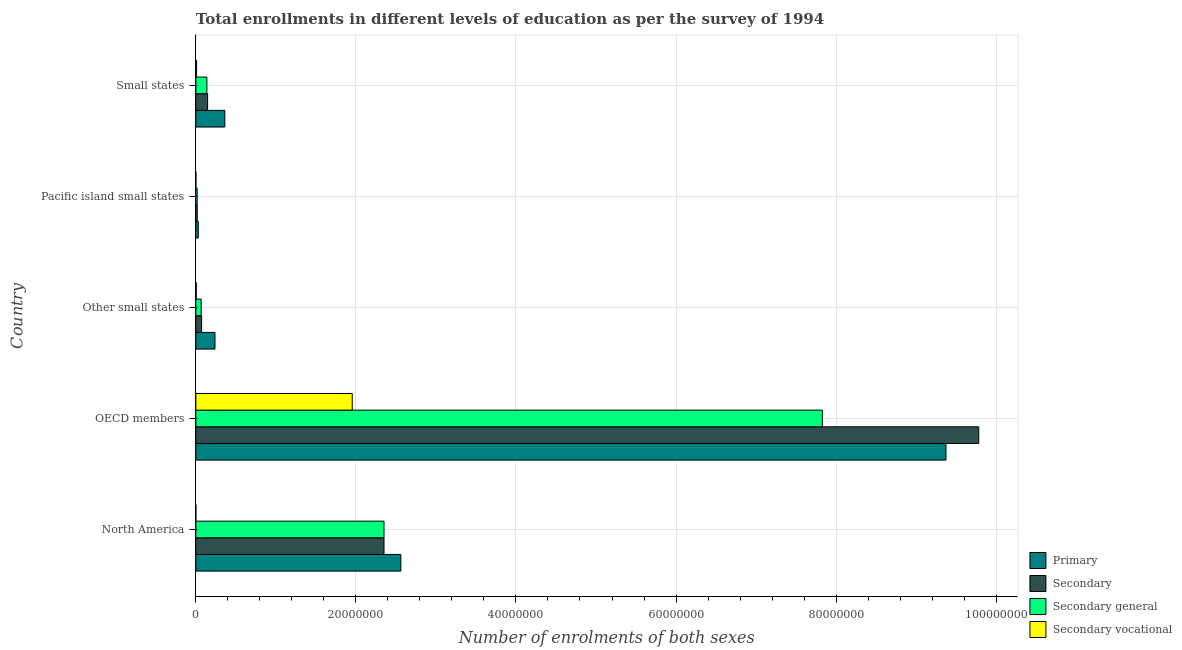How many different coloured bars are there?
Provide a succinct answer. 4. How many groups of bars are there?
Offer a very short reply. 5. Are the number of bars per tick equal to the number of legend labels?
Offer a very short reply. Yes. How many bars are there on the 2nd tick from the top?
Make the answer very short. 4. How many bars are there on the 5th tick from the bottom?
Your answer should be very brief. 4. What is the label of the 3rd group of bars from the top?
Keep it short and to the point. Other small states. What is the number of enrolments in secondary vocational education in Other small states?
Your answer should be compact. 5.53e+04. Across all countries, what is the maximum number of enrolments in primary education?
Ensure brevity in your answer.  9.37e+07. Across all countries, what is the minimum number of enrolments in secondary education?
Provide a succinct answer. 1.76e+05. In which country was the number of enrolments in secondary general education maximum?
Offer a very short reply. OECD members. What is the total number of enrolments in secondary general education in the graph?
Your answer should be very brief. 1.04e+08. What is the difference between the number of enrolments in secondary general education in Pacific island small states and that in Small states?
Ensure brevity in your answer.  -1.21e+06. What is the difference between the number of enrolments in secondary general education in Pacific island small states and the number of enrolments in primary education in North America?
Keep it short and to the point. -2.55e+07. What is the average number of enrolments in primary education per country?
Provide a short and direct response. 2.51e+07. What is the difference between the number of enrolments in secondary vocational education and number of enrolments in secondary general education in Small states?
Keep it short and to the point. -1.29e+06. In how many countries, is the number of enrolments in primary education greater than 8000000 ?
Your answer should be compact. 2. What is the ratio of the number of enrolments in primary education in North America to that in Small states?
Provide a succinct answer. 7.07. Is the difference between the number of enrolments in secondary education in North America and Other small states greater than the difference between the number of enrolments in secondary vocational education in North America and Other small states?
Your answer should be compact. Yes. What is the difference between the highest and the second highest number of enrolments in primary education?
Make the answer very short. 6.81e+07. What is the difference between the highest and the lowest number of enrolments in primary education?
Your response must be concise. 9.34e+07. Is it the case that in every country, the sum of the number of enrolments in secondary vocational education and number of enrolments in secondary education is greater than the sum of number of enrolments in secondary general education and number of enrolments in primary education?
Make the answer very short. Yes. What does the 1st bar from the top in North America represents?
Ensure brevity in your answer.  Secondary vocational. What does the 3rd bar from the bottom in Pacific island small states represents?
Provide a succinct answer. Secondary general. Is it the case that in every country, the sum of the number of enrolments in primary education and number of enrolments in secondary education is greater than the number of enrolments in secondary general education?
Make the answer very short. Yes. How many bars are there?
Your answer should be very brief. 20. How many countries are there in the graph?
Provide a short and direct response. 5. Does the graph contain grids?
Ensure brevity in your answer.  Yes. Where does the legend appear in the graph?
Provide a short and direct response. Bottom right. How are the legend labels stacked?
Your answer should be very brief. Vertical. What is the title of the graph?
Keep it short and to the point. Total enrollments in different levels of education as per the survey of 1994. What is the label or title of the X-axis?
Provide a succinct answer. Number of enrolments of both sexes. What is the label or title of the Y-axis?
Provide a short and direct response. Country. What is the Number of enrolments of both sexes of Primary in North America?
Keep it short and to the point. 2.56e+07. What is the Number of enrolments of both sexes of Secondary in North America?
Your answer should be very brief. 2.35e+07. What is the Number of enrolments of both sexes of Secondary general in North America?
Offer a terse response. 2.35e+07. What is the Number of enrolments of both sexes in Secondary vocational in North America?
Offer a very short reply. 45.26. What is the Number of enrolments of both sexes of Primary in OECD members?
Give a very brief answer. 9.37e+07. What is the Number of enrolments of both sexes of Secondary in OECD members?
Offer a terse response. 9.78e+07. What is the Number of enrolments of both sexes in Secondary general in OECD members?
Give a very brief answer. 7.83e+07. What is the Number of enrolments of both sexes of Secondary vocational in OECD members?
Make the answer very short. 1.95e+07. What is the Number of enrolments of both sexes of Primary in Other small states?
Your response must be concise. 2.39e+06. What is the Number of enrolments of both sexes of Secondary in Other small states?
Make the answer very short. 7.22e+05. What is the Number of enrolments of both sexes in Secondary general in Other small states?
Offer a terse response. 6.66e+05. What is the Number of enrolments of both sexes of Secondary vocational in Other small states?
Your answer should be compact. 5.53e+04. What is the Number of enrolments of both sexes in Primary in Pacific island small states?
Keep it short and to the point. 3.11e+05. What is the Number of enrolments of both sexes of Secondary in Pacific island small states?
Make the answer very short. 1.76e+05. What is the Number of enrolments of both sexes of Secondary general in Pacific island small states?
Ensure brevity in your answer.  1.69e+05. What is the Number of enrolments of both sexes in Secondary vocational in Pacific island small states?
Keep it short and to the point. 7581.44. What is the Number of enrolments of both sexes of Primary in Small states?
Provide a short and direct response. 3.62e+06. What is the Number of enrolments of both sexes in Secondary in Small states?
Offer a very short reply. 1.47e+06. What is the Number of enrolments of both sexes of Secondary general in Small states?
Offer a terse response. 1.38e+06. What is the Number of enrolments of both sexes in Secondary vocational in Small states?
Provide a short and direct response. 9.29e+04. Across all countries, what is the maximum Number of enrolments of both sexes of Primary?
Provide a short and direct response. 9.37e+07. Across all countries, what is the maximum Number of enrolments of both sexes in Secondary?
Your response must be concise. 9.78e+07. Across all countries, what is the maximum Number of enrolments of both sexes of Secondary general?
Ensure brevity in your answer.  7.83e+07. Across all countries, what is the maximum Number of enrolments of both sexes in Secondary vocational?
Make the answer very short. 1.95e+07. Across all countries, what is the minimum Number of enrolments of both sexes in Primary?
Provide a short and direct response. 3.11e+05. Across all countries, what is the minimum Number of enrolments of both sexes in Secondary?
Keep it short and to the point. 1.76e+05. Across all countries, what is the minimum Number of enrolments of both sexes of Secondary general?
Keep it short and to the point. 1.69e+05. Across all countries, what is the minimum Number of enrolments of both sexes of Secondary vocational?
Provide a short and direct response. 45.26. What is the total Number of enrolments of both sexes of Primary in the graph?
Make the answer very short. 1.26e+08. What is the total Number of enrolments of both sexes in Secondary in the graph?
Offer a very short reply. 1.24e+08. What is the total Number of enrolments of both sexes of Secondary general in the graph?
Make the answer very short. 1.04e+08. What is the total Number of enrolments of both sexes of Secondary vocational in the graph?
Ensure brevity in your answer.  1.97e+07. What is the difference between the Number of enrolments of both sexes of Primary in North America and that in OECD members?
Keep it short and to the point. -6.81e+07. What is the difference between the Number of enrolments of both sexes in Secondary in North America and that in OECD members?
Give a very brief answer. -7.43e+07. What is the difference between the Number of enrolments of both sexes in Secondary general in North America and that in OECD members?
Your response must be concise. -5.48e+07. What is the difference between the Number of enrolments of both sexes of Secondary vocational in North America and that in OECD members?
Your answer should be very brief. -1.95e+07. What is the difference between the Number of enrolments of both sexes in Primary in North America and that in Other small states?
Make the answer very short. 2.32e+07. What is the difference between the Number of enrolments of both sexes of Secondary in North America and that in Other small states?
Give a very brief answer. 2.28e+07. What is the difference between the Number of enrolments of both sexes of Secondary general in North America and that in Other small states?
Provide a succinct answer. 2.28e+07. What is the difference between the Number of enrolments of both sexes in Secondary vocational in North America and that in Other small states?
Give a very brief answer. -5.52e+04. What is the difference between the Number of enrolments of both sexes of Primary in North America and that in Pacific island small states?
Offer a very short reply. 2.53e+07. What is the difference between the Number of enrolments of both sexes in Secondary in North America and that in Pacific island small states?
Provide a short and direct response. 2.33e+07. What is the difference between the Number of enrolments of both sexes in Secondary general in North America and that in Pacific island small states?
Offer a very short reply. 2.33e+07. What is the difference between the Number of enrolments of both sexes of Secondary vocational in North America and that in Pacific island small states?
Offer a very short reply. -7536.18. What is the difference between the Number of enrolments of both sexes in Primary in North America and that in Small states?
Your answer should be very brief. 2.20e+07. What is the difference between the Number of enrolments of both sexes of Secondary in North America and that in Small states?
Your answer should be very brief. 2.20e+07. What is the difference between the Number of enrolments of both sexes in Secondary general in North America and that in Small states?
Ensure brevity in your answer.  2.21e+07. What is the difference between the Number of enrolments of both sexes of Secondary vocational in North America and that in Small states?
Your answer should be compact. -9.29e+04. What is the difference between the Number of enrolments of both sexes in Primary in OECD members and that in Other small states?
Provide a short and direct response. 9.13e+07. What is the difference between the Number of enrolments of both sexes of Secondary in OECD members and that in Other small states?
Offer a very short reply. 9.71e+07. What is the difference between the Number of enrolments of both sexes in Secondary general in OECD members and that in Other small states?
Provide a succinct answer. 7.76e+07. What is the difference between the Number of enrolments of both sexes in Secondary vocational in OECD members and that in Other small states?
Provide a short and direct response. 1.95e+07. What is the difference between the Number of enrolments of both sexes in Primary in OECD members and that in Pacific island small states?
Keep it short and to the point. 9.34e+07. What is the difference between the Number of enrolments of both sexes in Secondary in OECD members and that in Pacific island small states?
Keep it short and to the point. 9.77e+07. What is the difference between the Number of enrolments of both sexes of Secondary general in OECD members and that in Pacific island small states?
Provide a short and direct response. 7.81e+07. What is the difference between the Number of enrolments of both sexes in Secondary vocational in OECD members and that in Pacific island small states?
Provide a short and direct response. 1.95e+07. What is the difference between the Number of enrolments of both sexes of Primary in OECD members and that in Small states?
Make the answer very short. 9.01e+07. What is the difference between the Number of enrolments of both sexes in Secondary in OECD members and that in Small states?
Provide a short and direct response. 9.64e+07. What is the difference between the Number of enrolments of both sexes of Secondary general in OECD members and that in Small states?
Provide a short and direct response. 7.69e+07. What is the difference between the Number of enrolments of both sexes in Secondary vocational in OECD members and that in Small states?
Provide a succinct answer. 1.95e+07. What is the difference between the Number of enrolments of both sexes in Primary in Other small states and that in Pacific island small states?
Your answer should be compact. 2.08e+06. What is the difference between the Number of enrolments of both sexes in Secondary in Other small states and that in Pacific island small states?
Your answer should be very brief. 5.45e+05. What is the difference between the Number of enrolments of both sexes of Secondary general in Other small states and that in Pacific island small states?
Provide a succinct answer. 4.98e+05. What is the difference between the Number of enrolments of both sexes of Secondary vocational in Other small states and that in Pacific island small states?
Offer a very short reply. 4.77e+04. What is the difference between the Number of enrolments of both sexes in Primary in Other small states and that in Small states?
Your answer should be compact. -1.23e+06. What is the difference between the Number of enrolments of both sexes in Secondary in Other small states and that in Small states?
Offer a very short reply. -7.50e+05. What is the difference between the Number of enrolments of both sexes of Secondary general in Other small states and that in Small states?
Your answer should be very brief. -7.13e+05. What is the difference between the Number of enrolments of both sexes in Secondary vocational in Other small states and that in Small states?
Your response must be concise. -3.76e+04. What is the difference between the Number of enrolments of both sexes of Primary in Pacific island small states and that in Small states?
Offer a very short reply. -3.31e+06. What is the difference between the Number of enrolments of both sexes of Secondary in Pacific island small states and that in Small states?
Your answer should be very brief. -1.30e+06. What is the difference between the Number of enrolments of both sexes of Secondary general in Pacific island small states and that in Small states?
Keep it short and to the point. -1.21e+06. What is the difference between the Number of enrolments of both sexes of Secondary vocational in Pacific island small states and that in Small states?
Your response must be concise. -8.53e+04. What is the difference between the Number of enrolments of both sexes of Primary in North America and the Number of enrolments of both sexes of Secondary in OECD members?
Ensure brevity in your answer.  -7.22e+07. What is the difference between the Number of enrolments of both sexes in Primary in North America and the Number of enrolments of both sexes in Secondary general in OECD members?
Provide a succinct answer. -5.27e+07. What is the difference between the Number of enrolments of both sexes in Primary in North America and the Number of enrolments of both sexes in Secondary vocational in OECD members?
Your answer should be very brief. 6.08e+06. What is the difference between the Number of enrolments of both sexes in Secondary in North America and the Number of enrolments of both sexes in Secondary general in OECD members?
Keep it short and to the point. -5.48e+07. What is the difference between the Number of enrolments of both sexes of Secondary in North America and the Number of enrolments of both sexes of Secondary vocational in OECD members?
Your response must be concise. 3.97e+06. What is the difference between the Number of enrolments of both sexes in Secondary general in North America and the Number of enrolments of both sexes in Secondary vocational in OECD members?
Your response must be concise. 3.97e+06. What is the difference between the Number of enrolments of both sexes of Primary in North America and the Number of enrolments of both sexes of Secondary in Other small states?
Your response must be concise. 2.49e+07. What is the difference between the Number of enrolments of both sexes of Primary in North America and the Number of enrolments of both sexes of Secondary general in Other small states?
Your answer should be very brief. 2.50e+07. What is the difference between the Number of enrolments of both sexes in Primary in North America and the Number of enrolments of both sexes in Secondary vocational in Other small states?
Provide a succinct answer. 2.56e+07. What is the difference between the Number of enrolments of both sexes in Secondary in North America and the Number of enrolments of both sexes in Secondary general in Other small states?
Provide a short and direct response. 2.28e+07. What is the difference between the Number of enrolments of both sexes of Secondary in North America and the Number of enrolments of both sexes of Secondary vocational in Other small states?
Make the answer very short. 2.35e+07. What is the difference between the Number of enrolments of both sexes in Secondary general in North America and the Number of enrolments of both sexes in Secondary vocational in Other small states?
Provide a short and direct response. 2.35e+07. What is the difference between the Number of enrolments of both sexes of Primary in North America and the Number of enrolments of both sexes of Secondary in Pacific island small states?
Your response must be concise. 2.54e+07. What is the difference between the Number of enrolments of both sexes in Primary in North America and the Number of enrolments of both sexes in Secondary general in Pacific island small states?
Ensure brevity in your answer.  2.55e+07. What is the difference between the Number of enrolments of both sexes of Primary in North America and the Number of enrolments of both sexes of Secondary vocational in Pacific island small states?
Your response must be concise. 2.56e+07. What is the difference between the Number of enrolments of both sexes of Secondary in North America and the Number of enrolments of both sexes of Secondary general in Pacific island small states?
Make the answer very short. 2.33e+07. What is the difference between the Number of enrolments of both sexes of Secondary in North America and the Number of enrolments of both sexes of Secondary vocational in Pacific island small states?
Provide a short and direct response. 2.35e+07. What is the difference between the Number of enrolments of both sexes of Secondary general in North America and the Number of enrolments of both sexes of Secondary vocational in Pacific island small states?
Offer a very short reply. 2.35e+07. What is the difference between the Number of enrolments of both sexes of Primary in North America and the Number of enrolments of both sexes of Secondary in Small states?
Your answer should be very brief. 2.41e+07. What is the difference between the Number of enrolments of both sexes in Primary in North America and the Number of enrolments of both sexes in Secondary general in Small states?
Ensure brevity in your answer.  2.42e+07. What is the difference between the Number of enrolments of both sexes of Primary in North America and the Number of enrolments of both sexes of Secondary vocational in Small states?
Ensure brevity in your answer.  2.55e+07. What is the difference between the Number of enrolments of both sexes in Secondary in North America and the Number of enrolments of both sexes in Secondary general in Small states?
Your response must be concise. 2.21e+07. What is the difference between the Number of enrolments of both sexes of Secondary in North America and the Number of enrolments of both sexes of Secondary vocational in Small states?
Ensure brevity in your answer.  2.34e+07. What is the difference between the Number of enrolments of both sexes of Secondary general in North America and the Number of enrolments of both sexes of Secondary vocational in Small states?
Offer a terse response. 2.34e+07. What is the difference between the Number of enrolments of both sexes in Primary in OECD members and the Number of enrolments of both sexes in Secondary in Other small states?
Make the answer very short. 9.30e+07. What is the difference between the Number of enrolments of both sexes in Primary in OECD members and the Number of enrolments of both sexes in Secondary general in Other small states?
Offer a very short reply. 9.31e+07. What is the difference between the Number of enrolments of both sexes of Primary in OECD members and the Number of enrolments of both sexes of Secondary vocational in Other small states?
Provide a short and direct response. 9.37e+07. What is the difference between the Number of enrolments of both sexes of Secondary in OECD members and the Number of enrolments of both sexes of Secondary general in Other small states?
Offer a terse response. 9.72e+07. What is the difference between the Number of enrolments of both sexes of Secondary in OECD members and the Number of enrolments of both sexes of Secondary vocational in Other small states?
Offer a very short reply. 9.78e+07. What is the difference between the Number of enrolments of both sexes in Secondary general in OECD members and the Number of enrolments of both sexes in Secondary vocational in Other small states?
Ensure brevity in your answer.  7.82e+07. What is the difference between the Number of enrolments of both sexes of Primary in OECD members and the Number of enrolments of both sexes of Secondary in Pacific island small states?
Keep it short and to the point. 9.36e+07. What is the difference between the Number of enrolments of both sexes of Primary in OECD members and the Number of enrolments of both sexes of Secondary general in Pacific island small states?
Provide a short and direct response. 9.36e+07. What is the difference between the Number of enrolments of both sexes of Primary in OECD members and the Number of enrolments of both sexes of Secondary vocational in Pacific island small states?
Your answer should be compact. 9.37e+07. What is the difference between the Number of enrolments of both sexes of Secondary in OECD members and the Number of enrolments of both sexes of Secondary general in Pacific island small states?
Give a very brief answer. 9.77e+07. What is the difference between the Number of enrolments of both sexes of Secondary in OECD members and the Number of enrolments of both sexes of Secondary vocational in Pacific island small states?
Offer a very short reply. 9.78e+07. What is the difference between the Number of enrolments of both sexes of Secondary general in OECD members and the Number of enrolments of both sexes of Secondary vocational in Pacific island small states?
Keep it short and to the point. 7.83e+07. What is the difference between the Number of enrolments of both sexes in Primary in OECD members and the Number of enrolments of both sexes in Secondary in Small states?
Offer a very short reply. 9.23e+07. What is the difference between the Number of enrolments of both sexes of Primary in OECD members and the Number of enrolments of both sexes of Secondary general in Small states?
Keep it short and to the point. 9.24e+07. What is the difference between the Number of enrolments of both sexes in Primary in OECD members and the Number of enrolments of both sexes in Secondary vocational in Small states?
Make the answer very short. 9.36e+07. What is the difference between the Number of enrolments of both sexes of Secondary in OECD members and the Number of enrolments of both sexes of Secondary general in Small states?
Provide a short and direct response. 9.64e+07. What is the difference between the Number of enrolments of both sexes in Secondary in OECD members and the Number of enrolments of both sexes in Secondary vocational in Small states?
Provide a succinct answer. 9.77e+07. What is the difference between the Number of enrolments of both sexes in Secondary general in OECD members and the Number of enrolments of both sexes in Secondary vocational in Small states?
Provide a short and direct response. 7.82e+07. What is the difference between the Number of enrolments of both sexes in Primary in Other small states and the Number of enrolments of both sexes in Secondary in Pacific island small states?
Your response must be concise. 2.22e+06. What is the difference between the Number of enrolments of both sexes in Primary in Other small states and the Number of enrolments of both sexes in Secondary general in Pacific island small states?
Keep it short and to the point. 2.22e+06. What is the difference between the Number of enrolments of both sexes of Primary in Other small states and the Number of enrolments of both sexes of Secondary vocational in Pacific island small states?
Offer a terse response. 2.39e+06. What is the difference between the Number of enrolments of both sexes of Secondary in Other small states and the Number of enrolments of both sexes of Secondary general in Pacific island small states?
Offer a very short reply. 5.53e+05. What is the difference between the Number of enrolments of both sexes in Secondary in Other small states and the Number of enrolments of both sexes in Secondary vocational in Pacific island small states?
Your answer should be compact. 7.14e+05. What is the difference between the Number of enrolments of both sexes in Secondary general in Other small states and the Number of enrolments of both sexes in Secondary vocational in Pacific island small states?
Your answer should be very brief. 6.59e+05. What is the difference between the Number of enrolments of both sexes of Primary in Other small states and the Number of enrolments of both sexes of Secondary in Small states?
Keep it short and to the point. 9.21e+05. What is the difference between the Number of enrolments of both sexes of Primary in Other small states and the Number of enrolments of both sexes of Secondary general in Small states?
Make the answer very short. 1.01e+06. What is the difference between the Number of enrolments of both sexes of Primary in Other small states and the Number of enrolments of both sexes of Secondary vocational in Small states?
Your answer should be compact. 2.30e+06. What is the difference between the Number of enrolments of both sexes in Secondary in Other small states and the Number of enrolments of both sexes in Secondary general in Small states?
Ensure brevity in your answer.  -6.58e+05. What is the difference between the Number of enrolments of both sexes of Secondary in Other small states and the Number of enrolments of both sexes of Secondary vocational in Small states?
Your response must be concise. 6.29e+05. What is the difference between the Number of enrolments of both sexes in Secondary general in Other small states and the Number of enrolments of both sexes in Secondary vocational in Small states?
Provide a succinct answer. 5.74e+05. What is the difference between the Number of enrolments of both sexes in Primary in Pacific island small states and the Number of enrolments of both sexes in Secondary in Small states?
Your response must be concise. -1.16e+06. What is the difference between the Number of enrolments of both sexes of Primary in Pacific island small states and the Number of enrolments of both sexes of Secondary general in Small states?
Provide a succinct answer. -1.07e+06. What is the difference between the Number of enrolments of both sexes in Primary in Pacific island small states and the Number of enrolments of both sexes in Secondary vocational in Small states?
Offer a terse response. 2.18e+05. What is the difference between the Number of enrolments of both sexes in Secondary in Pacific island small states and the Number of enrolments of both sexes in Secondary general in Small states?
Offer a very short reply. -1.20e+06. What is the difference between the Number of enrolments of both sexes of Secondary in Pacific island small states and the Number of enrolments of both sexes of Secondary vocational in Small states?
Make the answer very short. 8.35e+04. What is the difference between the Number of enrolments of both sexes in Secondary general in Pacific island small states and the Number of enrolments of both sexes in Secondary vocational in Small states?
Make the answer very short. 7.59e+04. What is the average Number of enrolments of both sexes in Primary per country?
Provide a short and direct response. 2.51e+07. What is the average Number of enrolments of both sexes in Secondary per country?
Make the answer very short. 2.47e+07. What is the average Number of enrolments of both sexes of Secondary general per country?
Give a very brief answer. 2.08e+07. What is the average Number of enrolments of both sexes of Secondary vocational per country?
Provide a succinct answer. 3.94e+06. What is the difference between the Number of enrolments of both sexes in Primary and Number of enrolments of both sexes in Secondary in North America?
Make the answer very short. 2.10e+06. What is the difference between the Number of enrolments of both sexes in Primary and Number of enrolments of both sexes in Secondary general in North America?
Keep it short and to the point. 2.10e+06. What is the difference between the Number of enrolments of both sexes of Primary and Number of enrolments of both sexes of Secondary vocational in North America?
Ensure brevity in your answer.  2.56e+07. What is the difference between the Number of enrolments of both sexes in Secondary and Number of enrolments of both sexes in Secondary vocational in North America?
Your answer should be very brief. 2.35e+07. What is the difference between the Number of enrolments of both sexes in Secondary general and Number of enrolments of both sexes in Secondary vocational in North America?
Provide a short and direct response. 2.35e+07. What is the difference between the Number of enrolments of both sexes of Primary and Number of enrolments of both sexes of Secondary in OECD members?
Your response must be concise. -4.09e+06. What is the difference between the Number of enrolments of both sexes in Primary and Number of enrolments of both sexes in Secondary general in OECD members?
Offer a very short reply. 1.54e+07. What is the difference between the Number of enrolments of both sexes of Primary and Number of enrolments of both sexes of Secondary vocational in OECD members?
Give a very brief answer. 7.42e+07. What is the difference between the Number of enrolments of both sexes of Secondary and Number of enrolments of both sexes of Secondary general in OECD members?
Offer a terse response. 1.95e+07. What is the difference between the Number of enrolments of both sexes in Secondary and Number of enrolments of both sexes in Secondary vocational in OECD members?
Your response must be concise. 7.83e+07. What is the difference between the Number of enrolments of both sexes in Secondary general and Number of enrolments of both sexes in Secondary vocational in OECD members?
Keep it short and to the point. 5.87e+07. What is the difference between the Number of enrolments of both sexes in Primary and Number of enrolments of both sexes in Secondary in Other small states?
Ensure brevity in your answer.  1.67e+06. What is the difference between the Number of enrolments of both sexes in Primary and Number of enrolments of both sexes in Secondary general in Other small states?
Your response must be concise. 1.73e+06. What is the difference between the Number of enrolments of both sexes of Primary and Number of enrolments of both sexes of Secondary vocational in Other small states?
Your answer should be very brief. 2.34e+06. What is the difference between the Number of enrolments of both sexes of Secondary and Number of enrolments of both sexes of Secondary general in Other small states?
Your answer should be compact. 5.53e+04. What is the difference between the Number of enrolments of both sexes in Secondary and Number of enrolments of both sexes in Secondary vocational in Other small states?
Provide a short and direct response. 6.66e+05. What is the difference between the Number of enrolments of both sexes of Secondary general and Number of enrolments of both sexes of Secondary vocational in Other small states?
Give a very brief answer. 6.11e+05. What is the difference between the Number of enrolments of both sexes of Primary and Number of enrolments of both sexes of Secondary in Pacific island small states?
Provide a succinct answer. 1.35e+05. What is the difference between the Number of enrolments of both sexes in Primary and Number of enrolments of both sexes in Secondary general in Pacific island small states?
Make the answer very short. 1.42e+05. What is the difference between the Number of enrolments of both sexes of Primary and Number of enrolments of both sexes of Secondary vocational in Pacific island small states?
Provide a succinct answer. 3.03e+05. What is the difference between the Number of enrolments of both sexes of Secondary and Number of enrolments of both sexes of Secondary general in Pacific island small states?
Provide a succinct answer. 7581.45. What is the difference between the Number of enrolments of both sexes in Secondary and Number of enrolments of both sexes in Secondary vocational in Pacific island small states?
Give a very brief answer. 1.69e+05. What is the difference between the Number of enrolments of both sexes of Secondary general and Number of enrolments of both sexes of Secondary vocational in Pacific island small states?
Keep it short and to the point. 1.61e+05. What is the difference between the Number of enrolments of both sexes of Primary and Number of enrolments of both sexes of Secondary in Small states?
Offer a terse response. 2.15e+06. What is the difference between the Number of enrolments of both sexes of Primary and Number of enrolments of both sexes of Secondary general in Small states?
Ensure brevity in your answer.  2.24e+06. What is the difference between the Number of enrolments of both sexes of Primary and Number of enrolments of both sexes of Secondary vocational in Small states?
Offer a very short reply. 3.53e+06. What is the difference between the Number of enrolments of both sexes of Secondary and Number of enrolments of both sexes of Secondary general in Small states?
Keep it short and to the point. 9.29e+04. What is the difference between the Number of enrolments of both sexes of Secondary and Number of enrolments of both sexes of Secondary vocational in Small states?
Make the answer very short. 1.38e+06. What is the difference between the Number of enrolments of both sexes of Secondary general and Number of enrolments of both sexes of Secondary vocational in Small states?
Make the answer very short. 1.29e+06. What is the ratio of the Number of enrolments of both sexes in Primary in North America to that in OECD members?
Give a very brief answer. 0.27. What is the ratio of the Number of enrolments of both sexes in Secondary in North America to that in OECD members?
Your answer should be very brief. 0.24. What is the ratio of the Number of enrolments of both sexes in Secondary general in North America to that in OECD members?
Offer a terse response. 0.3. What is the ratio of the Number of enrolments of both sexes in Secondary vocational in North America to that in OECD members?
Provide a succinct answer. 0. What is the ratio of the Number of enrolments of both sexes in Primary in North America to that in Other small states?
Make the answer very short. 10.7. What is the ratio of the Number of enrolments of both sexes of Secondary in North America to that in Other small states?
Give a very brief answer. 32.58. What is the ratio of the Number of enrolments of both sexes in Secondary general in North America to that in Other small states?
Ensure brevity in your answer.  35.28. What is the ratio of the Number of enrolments of both sexes in Secondary vocational in North America to that in Other small states?
Provide a succinct answer. 0. What is the ratio of the Number of enrolments of both sexes of Primary in North America to that in Pacific island small states?
Keep it short and to the point. 82.36. What is the ratio of the Number of enrolments of both sexes of Secondary in North America to that in Pacific island small states?
Your answer should be very brief. 133.27. What is the ratio of the Number of enrolments of both sexes of Secondary general in North America to that in Pacific island small states?
Your answer should be very brief. 139.25. What is the ratio of the Number of enrolments of both sexes of Secondary vocational in North America to that in Pacific island small states?
Ensure brevity in your answer.  0.01. What is the ratio of the Number of enrolments of both sexes of Primary in North America to that in Small states?
Keep it short and to the point. 7.07. What is the ratio of the Number of enrolments of both sexes of Secondary in North America to that in Small states?
Your answer should be very brief. 15.97. What is the ratio of the Number of enrolments of both sexes of Secondary general in North America to that in Small states?
Your answer should be very brief. 17.05. What is the ratio of the Number of enrolments of both sexes in Secondary vocational in North America to that in Small states?
Offer a very short reply. 0. What is the ratio of the Number of enrolments of both sexes of Primary in OECD members to that in Other small states?
Your answer should be compact. 39.17. What is the ratio of the Number of enrolments of both sexes of Secondary in OECD members to that in Other small states?
Keep it short and to the point. 135.55. What is the ratio of the Number of enrolments of both sexes in Secondary general in OECD members to that in Other small states?
Your response must be concise. 117.46. What is the ratio of the Number of enrolments of both sexes in Secondary vocational in OECD members to that in Other small states?
Keep it short and to the point. 353.58. What is the ratio of the Number of enrolments of both sexes in Primary in OECD members to that in Pacific island small states?
Your response must be concise. 301.32. What is the ratio of the Number of enrolments of both sexes in Secondary in OECD members to that in Pacific island small states?
Provide a succinct answer. 554.45. What is the ratio of the Number of enrolments of both sexes of Secondary general in OECD members to that in Pacific island small states?
Offer a terse response. 463.61. What is the ratio of the Number of enrolments of both sexes in Secondary vocational in OECD members to that in Pacific island small states?
Provide a succinct answer. 2577.77. What is the ratio of the Number of enrolments of both sexes of Primary in OECD members to that in Small states?
Provide a short and direct response. 25.87. What is the ratio of the Number of enrolments of both sexes of Secondary in OECD members to that in Small states?
Give a very brief answer. 66.45. What is the ratio of the Number of enrolments of both sexes of Secondary general in OECD members to that in Small states?
Provide a short and direct response. 56.76. What is the ratio of the Number of enrolments of both sexes of Secondary vocational in OECD members to that in Small states?
Provide a short and direct response. 210.34. What is the ratio of the Number of enrolments of both sexes in Primary in Other small states to that in Pacific island small states?
Give a very brief answer. 7.69. What is the ratio of the Number of enrolments of both sexes of Secondary in Other small states to that in Pacific island small states?
Provide a short and direct response. 4.09. What is the ratio of the Number of enrolments of both sexes in Secondary general in Other small states to that in Pacific island small states?
Provide a succinct answer. 3.95. What is the ratio of the Number of enrolments of both sexes of Secondary vocational in Other small states to that in Pacific island small states?
Keep it short and to the point. 7.29. What is the ratio of the Number of enrolments of both sexes of Primary in Other small states to that in Small states?
Make the answer very short. 0.66. What is the ratio of the Number of enrolments of both sexes of Secondary in Other small states to that in Small states?
Your answer should be compact. 0.49. What is the ratio of the Number of enrolments of both sexes in Secondary general in Other small states to that in Small states?
Your answer should be compact. 0.48. What is the ratio of the Number of enrolments of both sexes of Secondary vocational in Other small states to that in Small states?
Keep it short and to the point. 0.59. What is the ratio of the Number of enrolments of both sexes of Primary in Pacific island small states to that in Small states?
Offer a terse response. 0.09. What is the ratio of the Number of enrolments of both sexes of Secondary in Pacific island small states to that in Small states?
Your answer should be very brief. 0.12. What is the ratio of the Number of enrolments of both sexes in Secondary general in Pacific island small states to that in Small states?
Make the answer very short. 0.12. What is the ratio of the Number of enrolments of both sexes in Secondary vocational in Pacific island small states to that in Small states?
Provide a succinct answer. 0.08. What is the difference between the highest and the second highest Number of enrolments of both sexes of Primary?
Make the answer very short. 6.81e+07. What is the difference between the highest and the second highest Number of enrolments of both sexes of Secondary?
Your response must be concise. 7.43e+07. What is the difference between the highest and the second highest Number of enrolments of both sexes of Secondary general?
Provide a short and direct response. 5.48e+07. What is the difference between the highest and the second highest Number of enrolments of both sexes in Secondary vocational?
Your response must be concise. 1.95e+07. What is the difference between the highest and the lowest Number of enrolments of both sexes in Primary?
Keep it short and to the point. 9.34e+07. What is the difference between the highest and the lowest Number of enrolments of both sexes in Secondary?
Provide a short and direct response. 9.77e+07. What is the difference between the highest and the lowest Number of enrolments of both sexes of Secondary general?
Keep it short and to the point. 7.81e+07. What is the difference between the highest and the lowest Number of enrolments of both sexes of Secondary vocational?
Offer a terse response. 1.95e+07. 